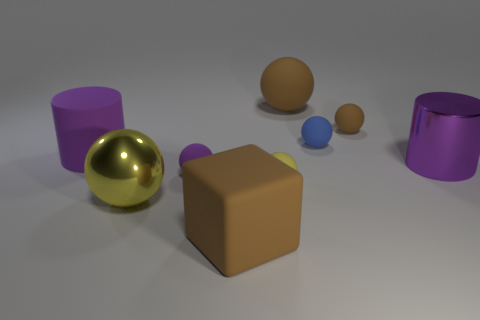Is the number of matte balls to the right of the large purple matte thing the same as the number of large objects?
Your answer should be very brief. Yes. What is the shape of the brown rubber object that is the same size as the brown matte block?
Your response must be concise. Sphere. What material is the big yellow object?
Your response must be concise. Metal. There is a thing that is in front of the small purple matte ball and on the right side of the big block; what is its color?
Provide a short and direct response. Yellow. Is the number of big cubes that are left of the purple matte ball the same as the number of things that are to the right of the purple rubber cylinder?
Your answer should be very brief. No. What is the color of the block that is made of the same material as the purple ball?
Your answer should be very brief. Brown. There is a big rubber cylinder; does it have the same color as the cylinder that is on the right side of the matte cylinder?
Offer a very short reply. Yes. Is there a large purple cylinder that is on the left side of the large cylinder right of the large purple thing on the left side of the tiny blue matte sphere?
Provide a succinct answer. Yes. What shape is the yellow object that is the same material as the tiny purple sphere?
Provide a short and direct response. Sphere. What shape is the large purple rubber object?
Offer a terse response. Cylinder. 